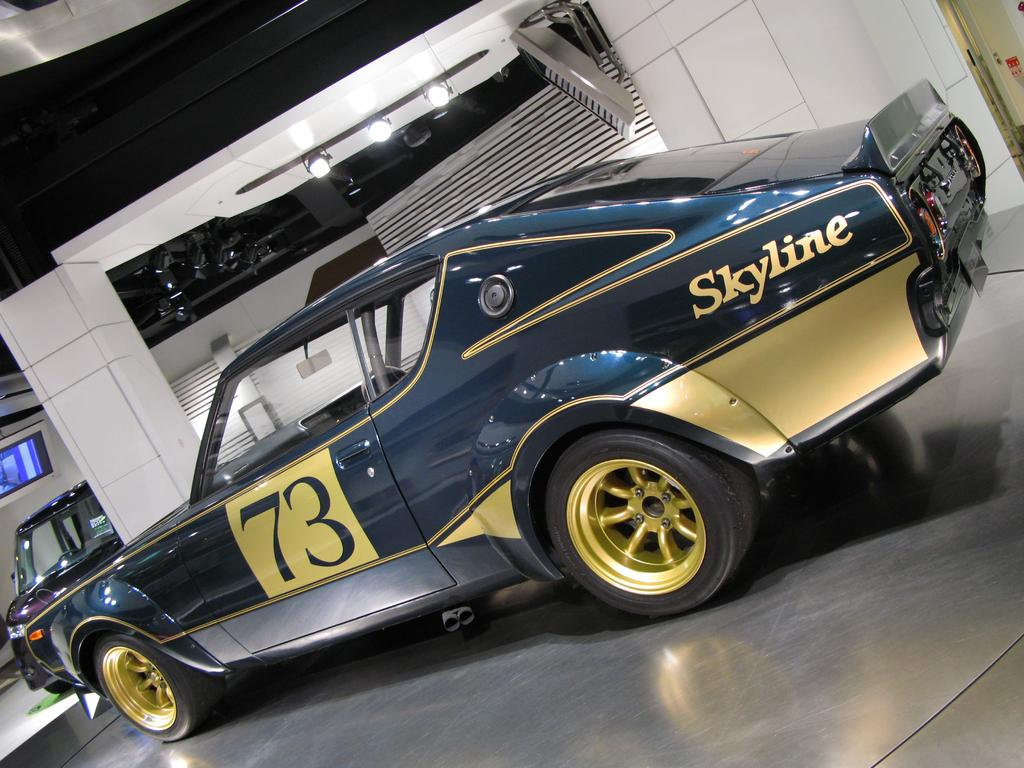What is the main subject of the image? The main subject of the image is a car. Can you describe the color of the car? The car is ash and yellow in color. What additional features can be seen on the car? There is text and a number on the car. What type of education does the car provide in the image? The image does not depict the car providing any education; it is simply a car with text and a number on it. 